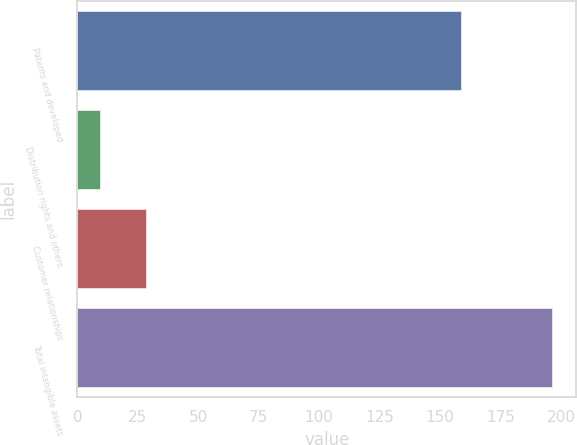Convert chart. <chart><loc_0><loc_0><loc_500><loc_500><bar_chart><fcel>Patents and developed<fcel>Distribution rights and others<fcel>Customer relationships<fcel>Total intangible assets<nl><fcel>158.7<fcel>9.2<fcel>28.6<fcel>196.5<nl></chart> 